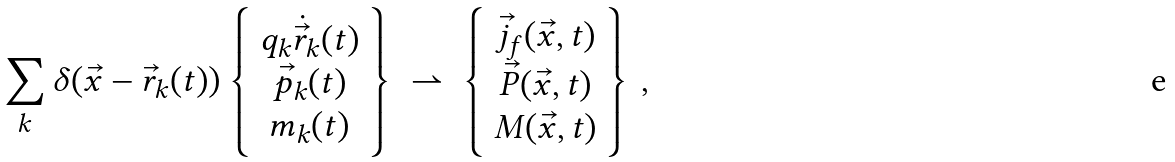Convert formula to latex. <formula><loc_0><loc_0><loc_500><loc_500>\sum _ { k } \delta ( \vec { x } - \vec { r } _ { k } ( t ) ) \left \{ \begin{array} { c } q _ { k } \dot { \vec { r } } _ { k } ( t ) \\ \vec { p } _ { k } ( t ) \\ m _ { k } ( t ) \\ \end{array} \right \} \ \rightharpoonup \ \left \{ \begin{array} { c } \vec { j } _ { f } ( \vec { x } , t ) \\ \vec { P } ( \vec { x } , t ) \\ M ( \vec { x } , t ) \\ \end{array} \right \} \, ,</formula> 